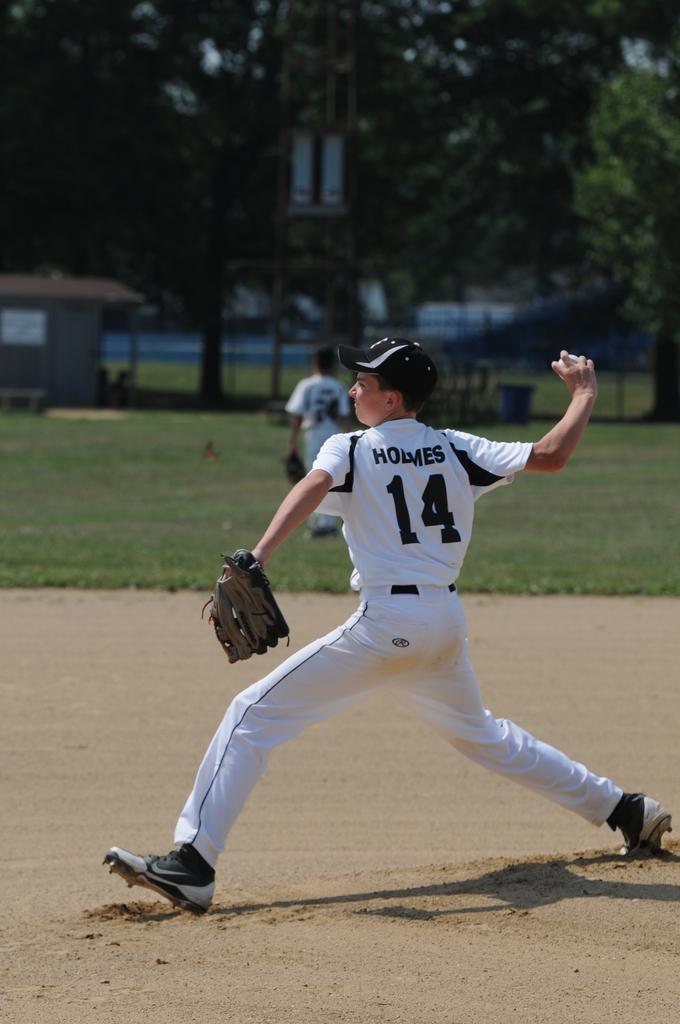What is the name above the number 14?
Ensure brevity in your answer.  Holmes. 